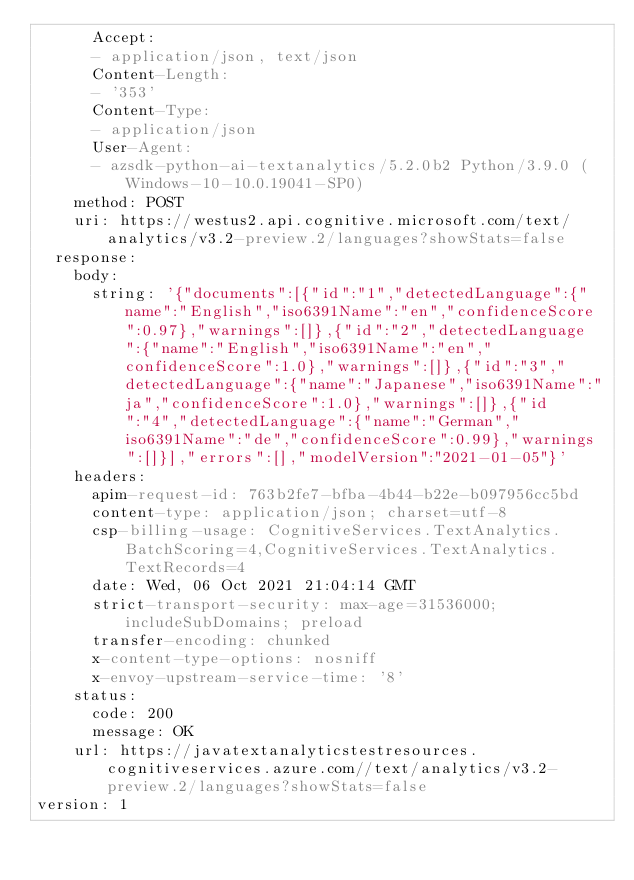Convert code to text. <code><loc_0><loc_0><loc_500><loc_500><_YAML_>      Accept:
      - application/json, text/json
      Content-Length:
      - '353'
      Content-Type:
      - application/json
      User-Agent:
      - azsdk-python-ai-textanalytics/5.2.0b2 Python/3.9.0 (Windows-10-10.0.19041-SP0)
    method: POST
    uri: https://westus2.api.cognitive.microsoft.com/text/analytics/v3.2-preview.2/languages?showStats=false
  response:
    body:
      string: '{"documents":[{"id":"1","detectedLanguage":{"name":"English","iso6391Name":"en","confidenceScore":0.97},"warnings":[]},{"id":"2","detectedLanguage":{"name":"English","iso6391Name":"en","confidenceScore":1.0},"warnings":[]},{"id":"3","detectedLanguage":{"name":"Japanese","iso6391Name":"ja","confidenceScore":1.0},"warnings":[]},{"id":"4","detectedLanguage":{"name":"German","iso6391Name":"de","confidenceScore":0.99},"warnings":[]}],"errors":[],"modelVersion":"2021-01-05"}'
    headers:
      apim-request-id: 763b2fe7-bfba-4b44-b22e-b097956cc5bd
      content-type: application/json; charset=utf-8
      csp-billing-usage: CognitiveServices.TextAnalytics.BatchScoring=4,CognitiveServices.TextAnalytics.TextRecords=4
      date: Wed, 06 Oct 2021 21:04:14 GMT
      strict-transport-security: max-age=31536000; includeSubDomains; preload
      transfer-encoding: chunked
      x-content-type-options: nosniff
      x-envoy-upstream-service-time: '8'
    status:
      code: 200
      message: OK
    url: https://javatextanalyticstestresources.cognitiveservices.azure.com//text/analytics/v3.2-preview.2/languages?showStats=false
version: 1
</code> 